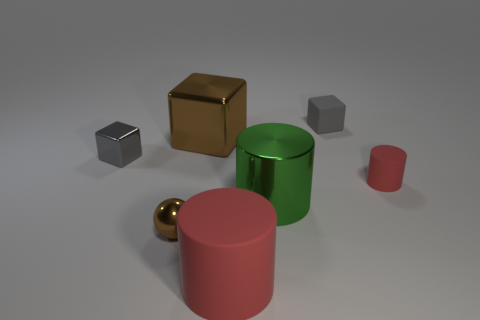Add 3 large green cylinders. How many objects exist? 10 Subtract all blocks. How many objects are left? 4 Subtract 1 gray cubes. How many objects are left? 6 Subtract all large cylinders. Subtract all tiny cylinders. How many objects are left? 4 Add 5 cylinders. How many cylinders are left? 8 Add 2 tiny yellow things. How many tiny yellow things exist? 2 